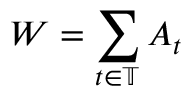Convert formula to latex. <formula><loc_0><loc_0><loc_500><loc_500>W = \sum _ { t \in \mathbb { T } } A _ { t }</formula> 